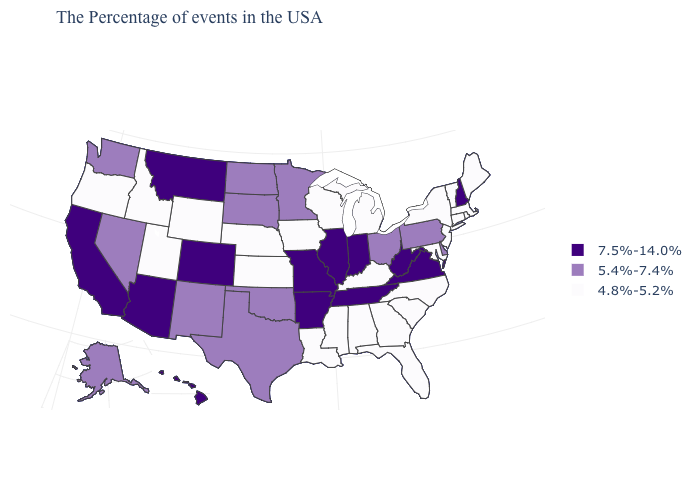Among the states that border Ohio , does Michigan have the lowest value?
Short answer required. Yes. Name the states that have a value in the range 4.8%-5.2%?
Quick response, please. Maine, Massachusetts, Rhode Island, Vermont, Connecticut, New York, New Jersey, Maryland, North Carolina, South Carolina, Florida, Georgia, Michigan, Kentucky, Alabama, Wisconsin, Mississippi, Louisiana, Iowa, Kansas, Nebraska, Wyoming, Utah, Idaho, Oregon. Name the states that have a value in the range 5.4%-7.4%?
Be succinct. Delaware, Pennsylvania, Ohio, Minnesota, Oklahoma, Texas, South Dakota, North Dakota, New Mexico, Nevada, Washington, Alaska. Does the map have missing data?
Give a very brief answer. No. What is the highest value in the USA?
Answer briefly. 7.5%-14.0%. Name the states that have a value in the range 4.8%-5.2%?
Be succinct. Maine, Massachusetts, Rhode Island, Vermont, Connecticut, New York, New Jersey, Maryland, North Carolina, South Carolina, Florida, Georgia, Michigan, Kentucky, Alabama, Wisconsin, Mississippi, Louisiana, Iowa, Kansas, Nebraska, Wyoming, Utah, Idaho, Oregon. Name the states that have a value in the range 7.5%-14.0%?
Quick response, please. New Hampshire, Virginia, West Virginia, Indiana, Tennessee, Illinois, Missouri, Arkansas, Colorado, Montana, Arizona, California, Hawaii. Does New York have the lowest value in the USA?
Quick response, please. Yes. Which states hav the highest value in the West?
Write a very short answer. Colorado, Montana, Arizona, California, Hawaii. Among the states that border West Virginia , does Ohio have the highest value?
Concise answer only. No. What is the value of Ohio?
Short answer required. 5.4%-7.4%. Name the states that have a value in the range 7.5%-14.0%?
Concise answer only. New Hampshire, Virginia, West Virginia, Indiana, Tennessee, Illinois, Missouri, Arkansas, Colorado, Montana, Arizona, California, Hawaii. What is the highest value in the USA?
Keep it brief. 7.5%-14.0%. Does Idaho have the same value as Nebraska?
Quick response, please. Yes. What is the highest value in states that border Maine?
Keep it brief. 7.5%-14.0%. 